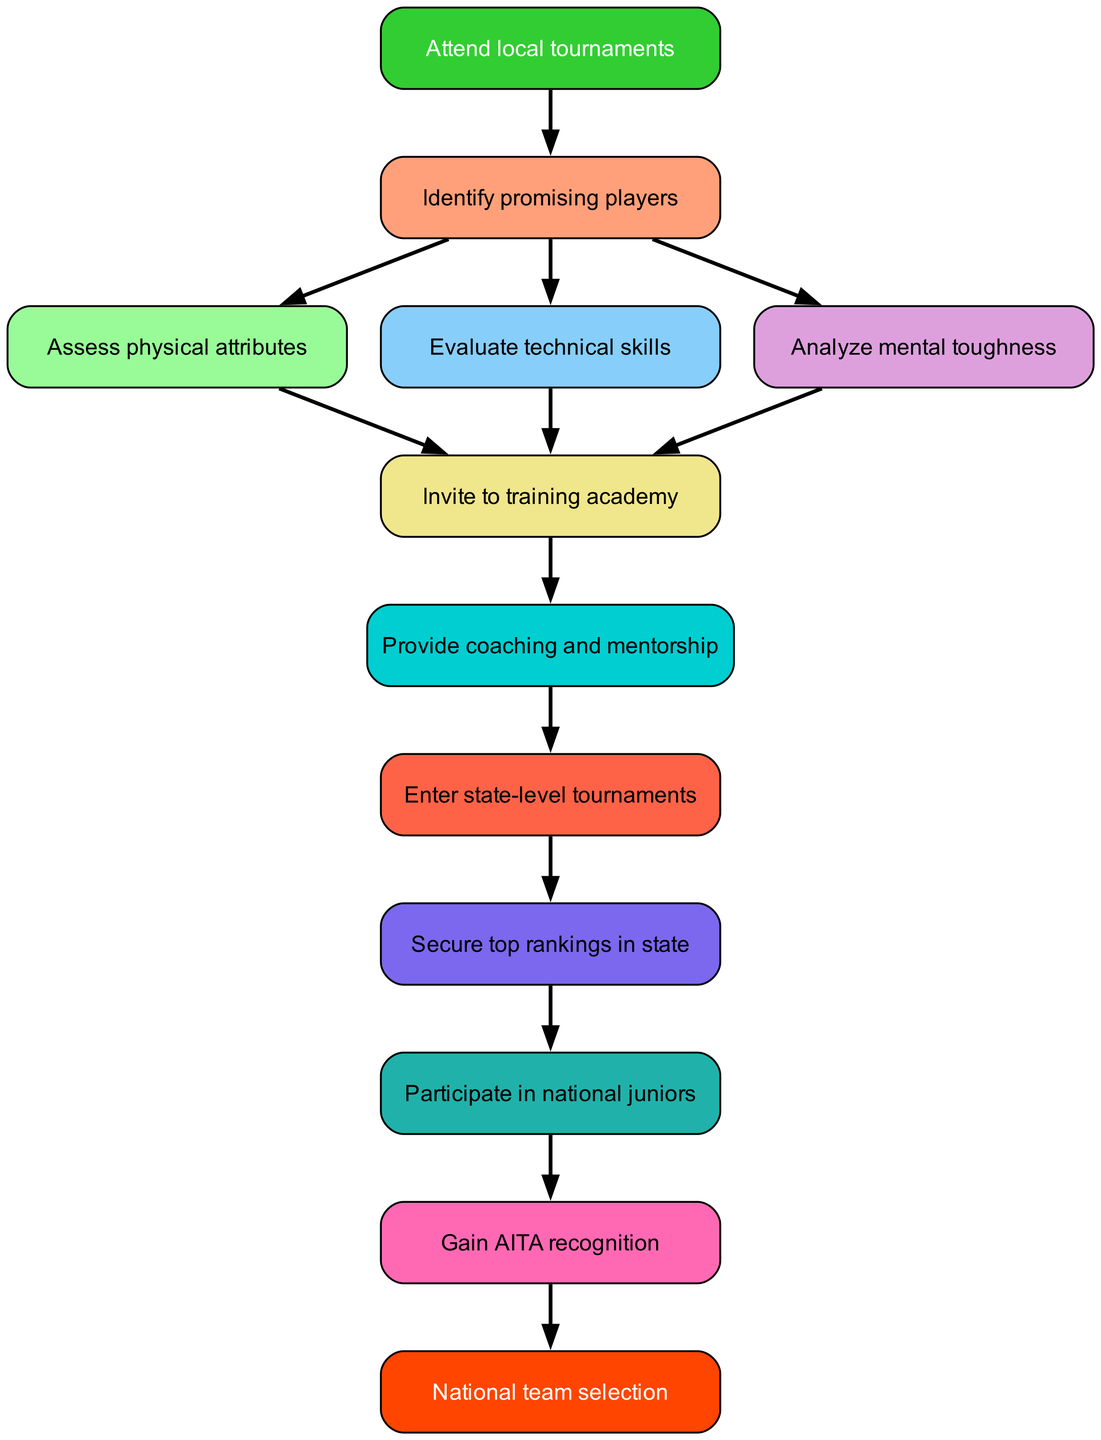What's the starting point of the process? The flow chart indicates that the process begins with "Attend local tournaments". This is the first node in the diagram and leads to the next step.
Answer: Attend local tournaments How many main assessment steps follow identifying promising players? After identifying promising players, there are three assessment steps listed: "Assess physical attributes", "Evaluate technical skills", and "Analyze mental toughness". Thus, there are three main steps.
Answer: 3 Which node leads directly to the national team selection? The final node is "National team selection". It is reached after gaining AITA recognition, which is the penultimate step in the diagram.
Answer: National team selection What is the step that follows providing coaching and mentorship? The diagram shows that after "Provide coaching and mentorship", the next step is "Enter state-level tournaments". This node follows sequentially in the process.
Answer: Enter state-level tournaments Which step comes before gaining AITA recognition? According to the flow chart, "Participate in national juniors" comes right before the step of gaining AITA recognition. This is the direct predecessor in the sequence.
Answer: Participate in national juniors What is the total number of steps between identifying promising players and national team selection? Starting from "Identify promising players" and counting the steps until "National team selection", there are nine steps: from "Identify promising players" to "National team selection".
Answer: 9 What do you analyze after assessing technical skills? Following the "Evaluate technical skills", the next step indicated in the diagram is "Analyze mental toughness". This shows the progression of assessments made.
Answer: Analyze mental toughness What is the color of the starting node? The starting node "Attend local tournaments" is colored in a green hue, specifically with the color code matching light green, which visually distinguishes the initial step.
Answer: Green 